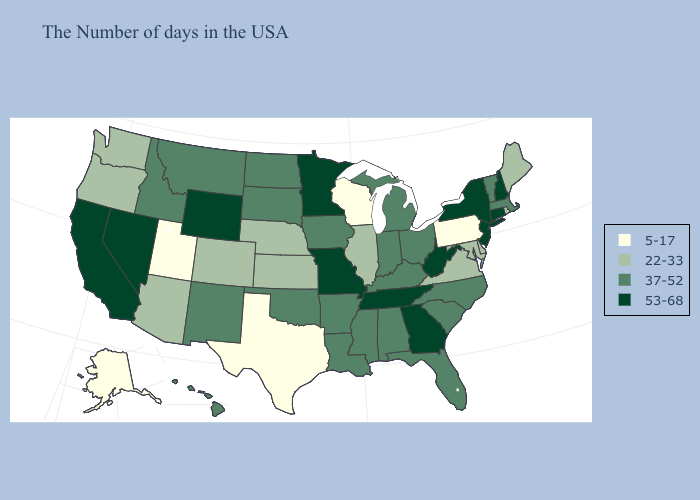How many symbols are there in the legend?
Keep it brief. 4. What is the lowest value in the USA?
Keep it brief. 5-17. Among the states that border Missouri , does Kentucky have the highest value?
Quick response, please. No. Among the states that border Florida , does Georgia have the lowest value?
Keep it brief. No. What is the value of Minnesota?
Answer briefly. 53-68. Does the map have missing data?
Be succinct. No. What is the highest value in the West ?
Concise answer only. 53-68. Name the states that have a value in the range 5-17?
Answer briefly. Pennsylvania, Wisconsin, Texas, Utah, Alaska. Name the states that have a value in the range 53-68?
Concise answer only. New Hampshire, Connecticut, New York, New Jersey, West Virginia, Georgia, Tennessee, Missouri, Minnesota, Wyoming, Nevada, California. What is the value of Massachusetts?
Short answer required. 37-52. What is the value of Oregon?
Write a very short answer. 22-33. What is the value of Maryland?
Keep it brief. 22-33. Name the states that have a value in the range 53-68?
Keep it brief. New Hampshire, Connecticut, New York, New Jersey, West Virginia, Georgia, Tennessee, Missouri, Minnesota, Wyoming, Nevada, California. Does the first symbol in the legend represent the smallest category?
Concise answer only. Yes. Which states have the lowest value in the South?
Answer briefly. Texas. 